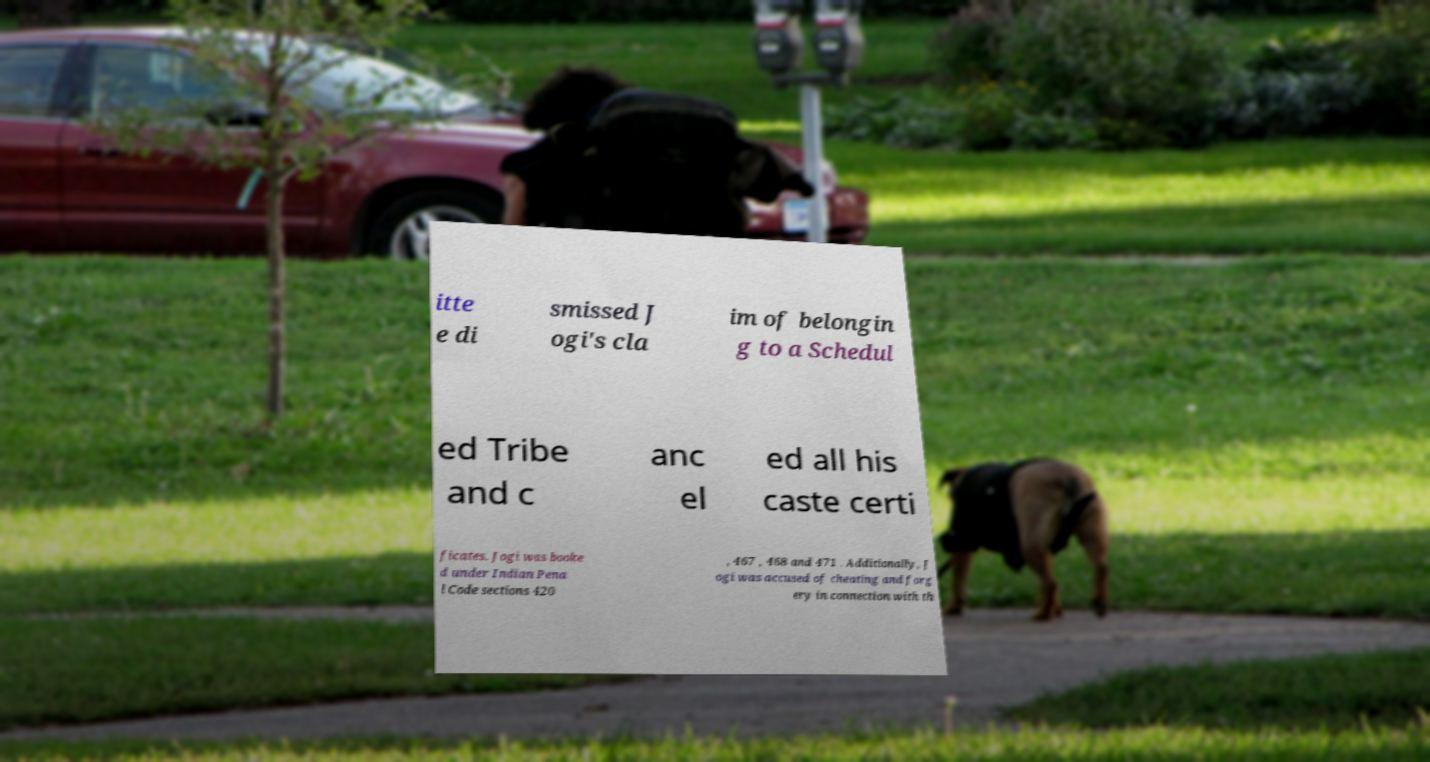Could you assist in decoding the text presented in this image and type it out clearly? itte e di smissed J ogi's cla im of belongin g to a Schedul ed Tribe and c anc el ed all his caste certi ficates. Jogi was booke d under Indian Pena l Code sections 420 , 467 , 468 and 471 . Additionally, J ogi was accused of cheating and forg ery in connection with th 